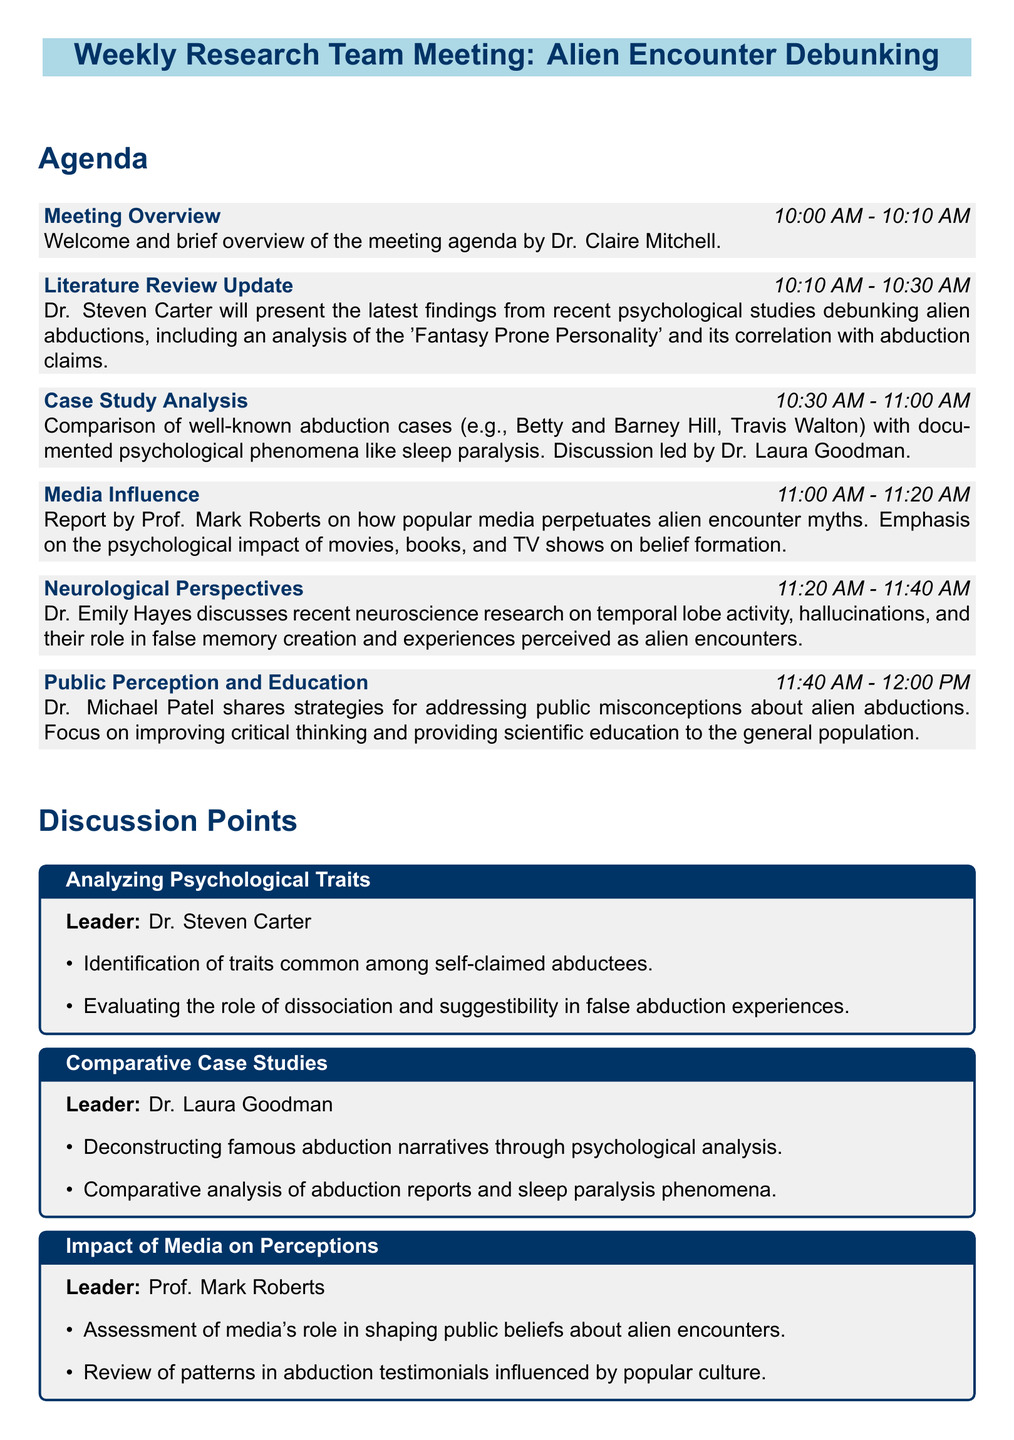What time does the meeting begin? The meeting begins at 10:00 AM as indicated in the agenda section.
Answer: 10:00 AM Who is leading the case study analysis? Dr. Laura Goodman is the leader of the case study analysis as mentioned in the agenda.
Answer: Dr. Laura Goodman What psychological model is discussed in the literature review update? The literature review update discusses the 'Fantasy Prone Personality' and its correlation with abduction claims.
Answer: Fantasy Prone Personality Which case studies are being compared in the case study analysis? The case studies being compared include Betty and Barney Hill and Travis Walton as specified in the agenda.
Answer: Betty and Barney Hill, Travis Walton What is the focus of Dr. Michael Patel's presentation? Dr. Michael Patel's presentation focuses on public misconceptions about alien abductions and strategies for addressing them.
Answer: Public misconceptions and education strategies How long is the media influence section? The media influence section lasts for 20 minutes, as stated in the agenda.
Answer: 20 minutes Which psychological phenomenon is compared with abduction reports? The phenomenon compared with abduction reports is sleep paralysis, mentioned in the comparative case studies discussion point.
Answer: Sleep paralysis What is one of the strategies discussed for promoting critical thinking? One of the strategies discussed is designing public outreach programs for science-based education.
Answer: Public outreach programs What is the total duration of the meeting? The total duration of the meeting can be calculated by adding all segments in the agenda, which amounts to 120 minutes.
Answer: 120 minutes 